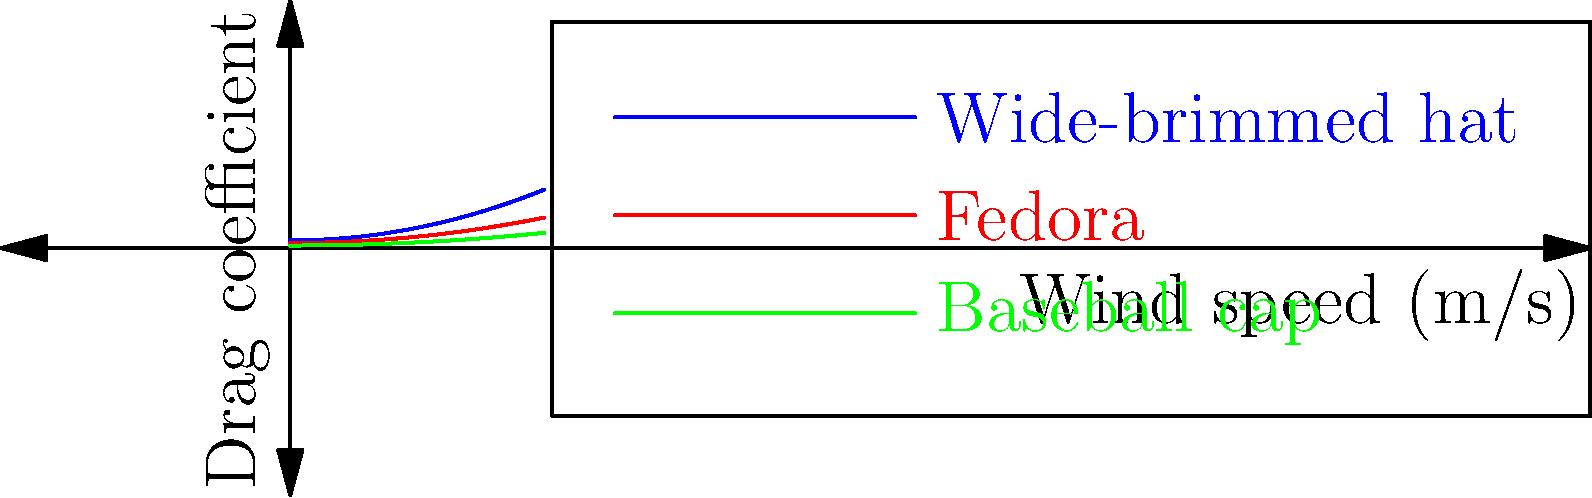The graph shows the drag coefficient versus wind speed for three different hat designs tested in a wind tunnel. Based on the aerodynamic properties illustrated, which hat design would be most suitable for a fashion-forward individual attending an outdoor event on a particularly windy day, considering both style and functionality? To answer this question, we need to analyze the graph and consider both aerodynamic properties and fashion implications:

1. Interpret the graph:
   - The x-axis represents wind speed in m/s.
   - The y-axis represents the drag coefficient.
   - Lower drag coefficients indicate better aerodynamic performance.

2. Compare the three hat designs:
   - Wide-brimmed hat (blue curve): Highest drag coefficient at all wind speeds.
   - Fedora (red curve): Moderate drag coefficient.
   - Baseball cap (green curve): Lowest drag coefficient at all wind speeds.

3. Consider aerodynamic performance:
   - The baseball cap has the best aerodynamic properties, followed by the fedora, then the wide-brimmed hat.

4. Evaluate fashion considerations:
   - Wide-brimmed hats and fedoras are generally considered more fashionable for formal outdoor events.
   - Baseball caps are more casual and may not be suitable for all occasions.

5. Balance functionality and style:
   - The fedora offers a good compromise between aerodynamic performance and fashion.
   - It has better wind resistance than the wide-brimmed hat but maintains a stylish appearance.

6. Consider the specific scenario:
   - For a windy day, aerodynamic properties become more important.
   - The fedora's moderate drag coefficient will help it stay on the wearer's head better than the wide-brimmed hat.

Therefore, the fedora would be the most suitable choice for a fashion-forward individual attending an outdoor event on a windy day, as it balances style with improved aerodynamic performance compared to the wide-brimmed hat.
Answer: Fedora 